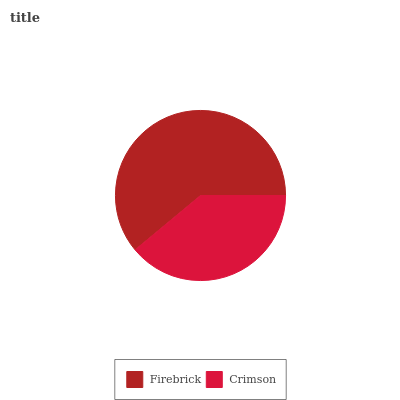Is Crimson the minimum?
Answer yes or no. Yes. Is Firebrick the maximum?
Answer yes or no. Yes. Is Crimson the maximum?
Answer yes or no. No. Is Firebrick greater than Crimson?
Answer yes or no. Yes. Is Crimson less than Firebrick?
Answer yes or no. Yes. Is Crimson greater than Firebrick?
Answer yes or no. No. Is Firebrick less than Crimson?
Answer yes or no. No. Is Firebrick the high median?
Answer yes or no. Yes. Is Crimson the low median?
Answer yes or no. Yes. Is Crimson the high median?
Answer yes or no. No. Is Firebrick the low median?
Answer yes or no. No. 